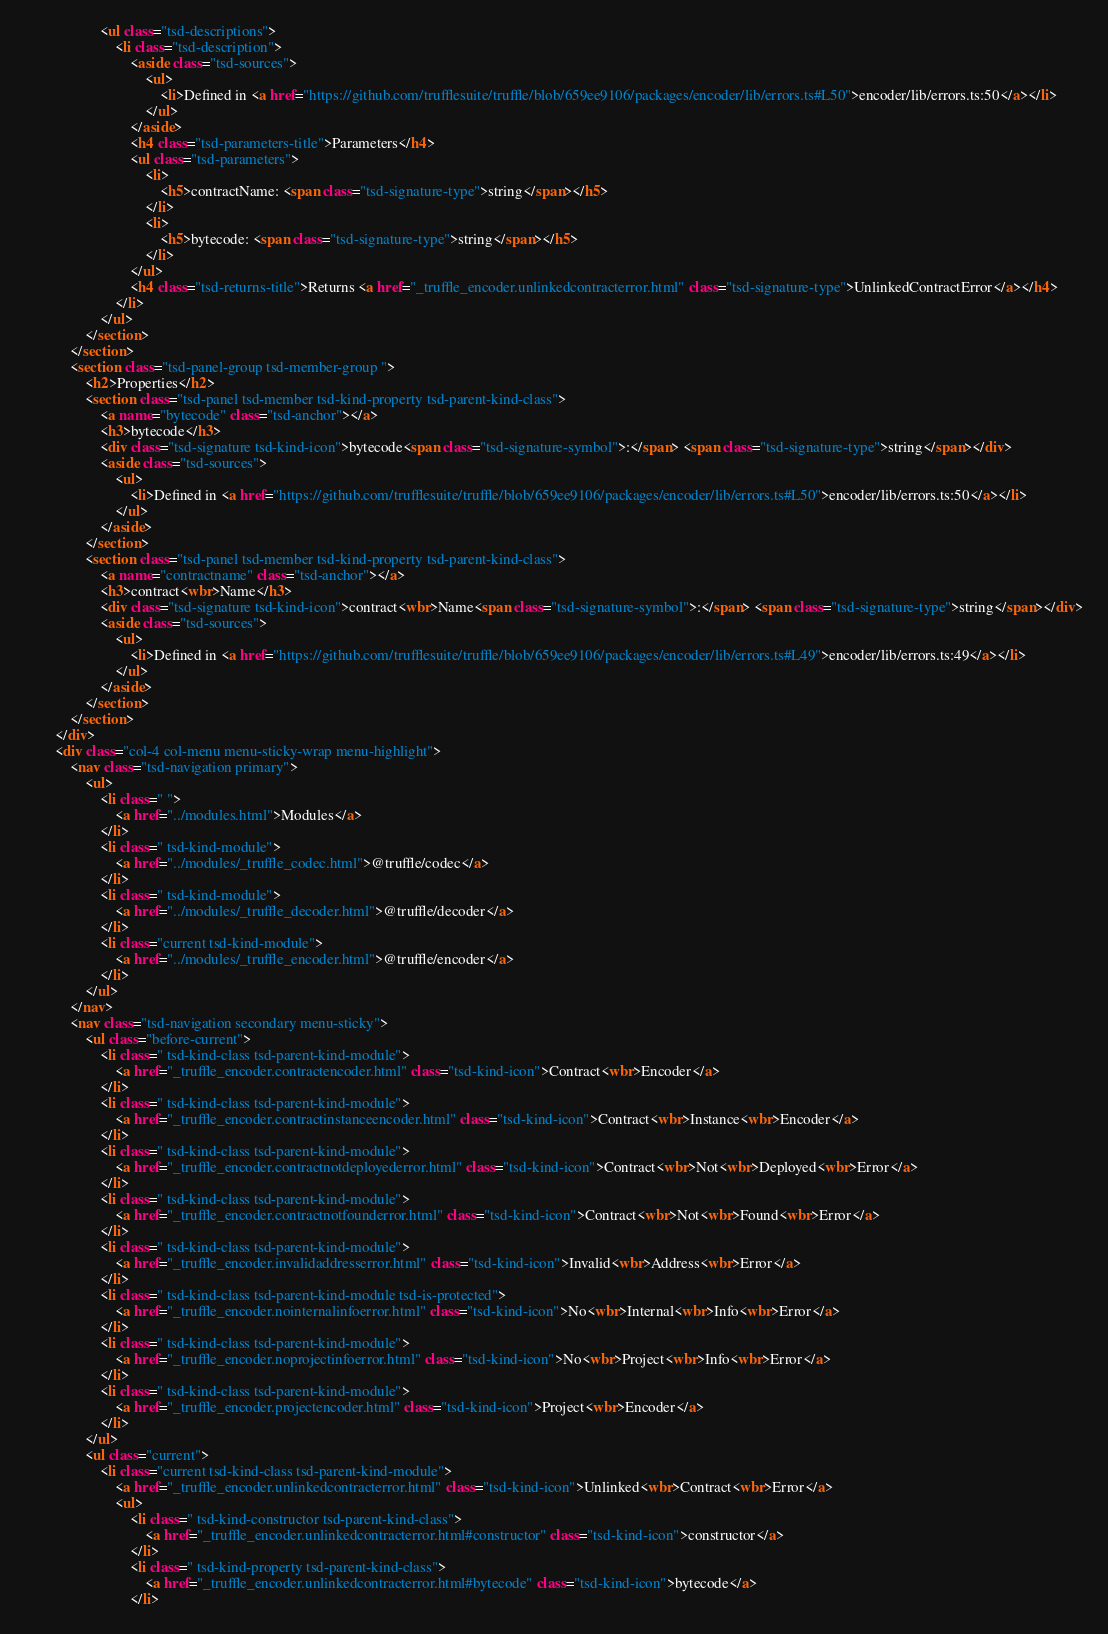Convert code to text. <code><loc_0><loc_0><loc_500><loc_500><_HTML_>					<ul class="tsd-descriptions">
						<li class="tsd-description">
							<aside class="tsd-sources">
								<ul>
									<li>Defined in <a href="https://github.com/trufflesuite/truffle/blob/659ee9106/packages/encoder/lib/errors.ts#L50">encoder/lib/errors.ts:50</a></li>
								</ul>
							</aside>
							<h4 class="tsd-parameters-title">Parameters</h4>
							<ul class="tsd-parameters">
								<li>
									<h5>contractName: <span class="tsd-signature-type">string</span></h5>
								</li>
								<li>
									<h5>bytecode: <span class="tsd-signature-type">string</span></h5>
								</li>
							</ul>
							<h4 class="tsd-returns-title">Returns <a href="_truffle_encoder.unlinkedcontracterror.html" class="tsd-signature-type">UnlinkedContractError</a></h4>
						</li>
					</ul>
				</section>
			</section>
			<section class="tsd-panel-group tsd-member-group ">
				<h2>Properties</h2>
				<section class="tsd-panel tsd-member tsd-kind-property tsd-parent-kind-class">
					<a name="bytecode" class="tsd-anchor"></a>
					<h3>bytecode</h3>
					<div class="tsd-signature tsd-kind-icon">bytecode<span class="tsd-signature-symbol">:</span> <span class="tsd-signature-type">string</span></div>
					<aside class="tsd-sources">
						<ul>
							<li>Defined in <a href="https://github.com/trufflesuite/truffle/blob/659ee9106/packages/encoder/lib/errors.ts#L50">encoder/lib/errors.ts:50</a></li>
						</ul>
					</aside>
				</section>
				<section class="tsd-panel tsd-member tsd-kind-property tsd-parent-kind-class">
					<a name="contractname" class="tsd-anchor"></a>
					<h3>contract<wbr>Name</h3>
					<div class="tsd-signature tsd-kind-icon">contract<wbr>Name<span class="tsd-signature-symbol">:</span> <span class="tsd-signature-type">string</span></div>
					<aside class="tsd-sources">
						<ul>
							<li>Defined in <a href="https://github.com/trufflesuite/truffle/blob/659ee9106/packages/encoder/lib/errors.ts#L49">encoder/lib/errors.ts:49</a></li>
						</ul>
					</aside>
				</section>
			</section>
		</div>
		<div class="col-4 col-menu menu-sticky-wrap menu-highlight">
			<nav class="tsd-navigation primary">
				<ul>
					<li class=" ">
						<a href="../modules.html">Modules</a>
					</li>
					<li class=" tsd-kind-module">
						<a href="../modules/_truffle_codec.html">@truffle/codec</a>
					</li>
					<li class=" tsd-kind-module">
						<a href="../modules/_truffle_decoder.html">@truffle/decoder</a>
					</li>
					<li class="current tsd-kind-module">
						<a href="../modules/_truffle_encoder.html">@truffle/encoder</a>
					</li>
				</ul>
			</nav>
			<nav class="tsd-navigation secondary menu-sticky">
				<ul class="before-current">
					<li class=" tsd-kind-class tsd-parent-kind-module">
						<a href="_truffle_encoder.contractencoder.html" class="tsd-kind-icon">Contract<wbr>Encoder</a>
					</li>
					<li class=" tsd-kind-class tsd-parent-kind-module">
						<a href="_truffle_encoder.contractinstanceencoder.html" class="tsd-kind-icon">Contract<wbr>Instance<wbr>Encoder</a>
					</li>
					<li class=" tsd-kind-class tsd-parent-kind-module">
						<a href="_truffle_encoder.contractnotdeployederror.html" class="tsd-kind-icon">Contract<wbr>Not<wbr>Deployed<wbr>Error</a>
					</li>
					<li class=" tsd-kind-class tsd-parent-kind-module">
						<a href="_truffle_encoder.contractnotfounderror.html" class="tsd-kind-icon">Contract<wbr>Not<wbr>Found<wbr>Error</a>
					</li>
					<li class=" tsd-kind-class tsd-parent-kind-module">
						<a href="_truffle_encoder.invalidaddresserror.html" class="tsd-kind-icon">Invalid<wbr>Address<wbr>Error</a>
					</li>
					<li class=" tsd-kind-class tsd-parent-kind-module tsd-is-protected">
						<a href="_truffle_encoder.nointernalinfoerror.html" class="tsd-kind-icon">No<wbr>Internal<wbr>Info<wbr>Error</a>
					</li>
					<li class=" tsd-kind-class tsd-parent-kind-module">
						<a href="_truffle_encoder.noprojectinfoerror.html" class="tsd-kind-icon">No<wbr>Project<wbr>Info<wbr>Error</a>
					</li>
					<li class=" tsd-kind-class tsd-parent-kind-module">
						<a href="_truffle_encoder.projectencoder.html" class="tsd-kind-icon">Project<wbr>Encoder</a>
					</li>
				</ul>
				<ul class="current">
					<li class="current tsd-kind-class tsd-parent-kind-module">
						<a href="_truffle_encoder.unlinkedcontracterror.html" class="tsd-kind-icon">Unlinked<wbr>Contract<wbr>Error</a>
						<ul>
							<li class=" tsd-kind-constructor tsd-parent-kind-class">
								<a href="_truffle_encoder.unlinkedcontracterror.html#constructor" class="tsd-kind-icon">constructor</a>
							</li>
							<li class=" tsd-kind-property tsd-parent-kind-class">
								<a href="_truffle_encoder.unlinkedcontracterror.html#bytecode" class="tsd-kind-icon">bytecode</a>
							</li></code> 